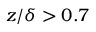Convert formula to latex. <formula><loc_0><loc_0><loc_500><loc_500>z / \delta > 0 . 7</formula> 